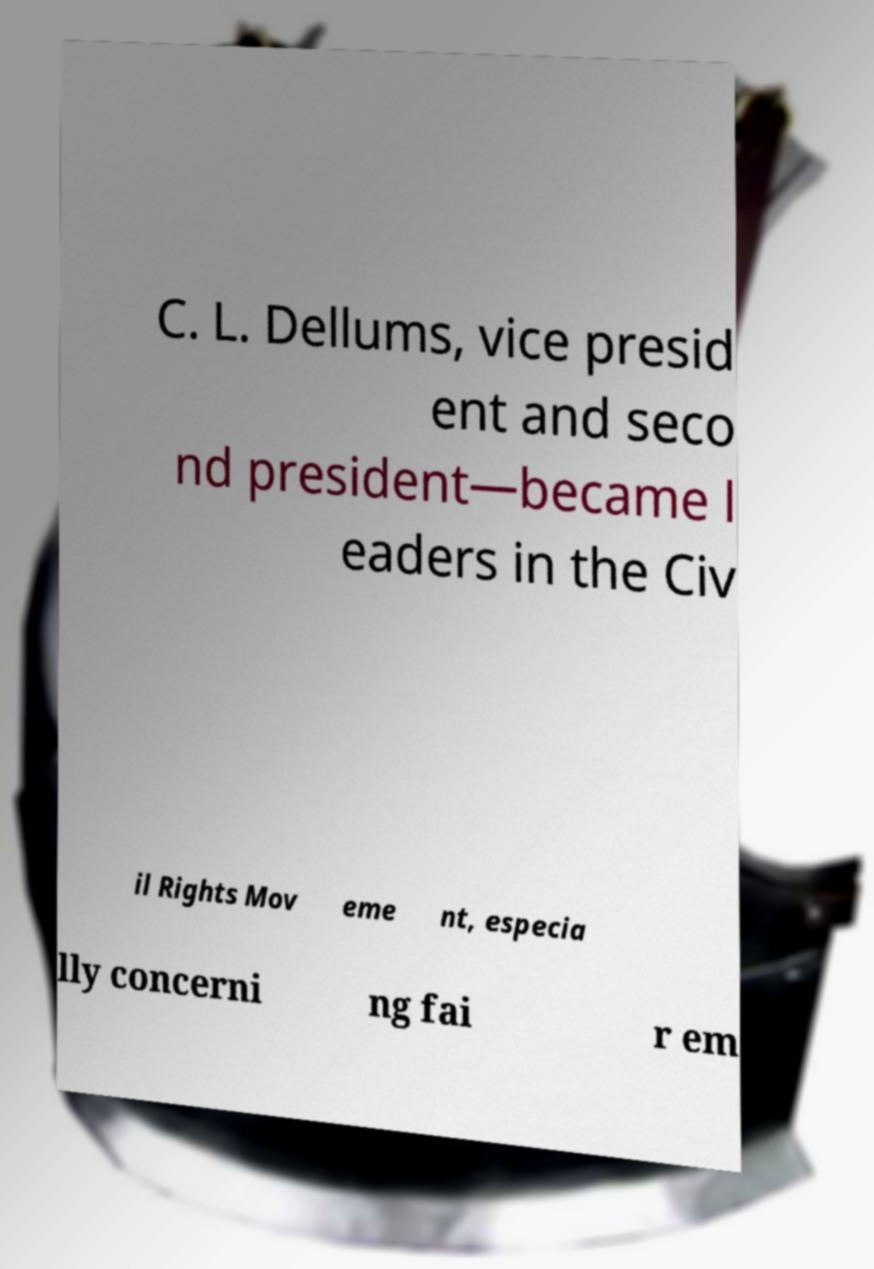For documentation purposes, I need the text within this image transcribed. Could you provide that? C. L. Dellums, vice presid ent and seco nd president—became l eaders in the Civ il Rights Mov eme nt, especia lly concerni ng fai r em 